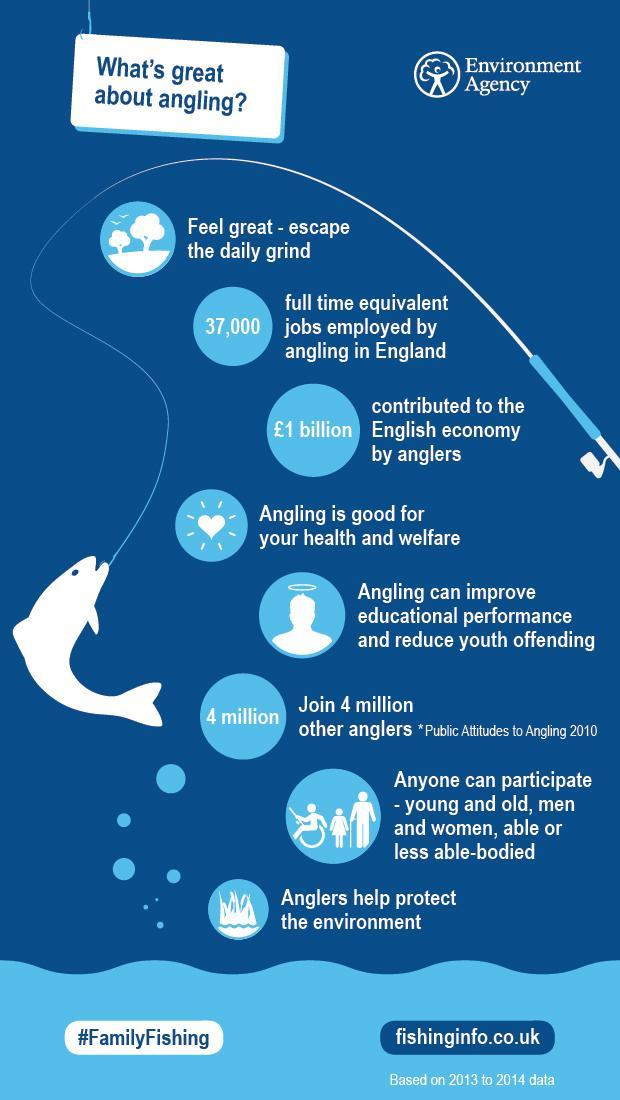How many anglers are there?
Answer the question with a short phrase. 4 million What is the colour of the fish - blue, white or green ? White What does the second circle stand for - number of jobs, education or economic contribution ? Number of jobs What image indicates angling is good for health - heart, trees or fish ? Heart In what sport can both men and women, young and old, abled and disabled participate ? Angling What is the other name for fishing with a rod ? Angling 